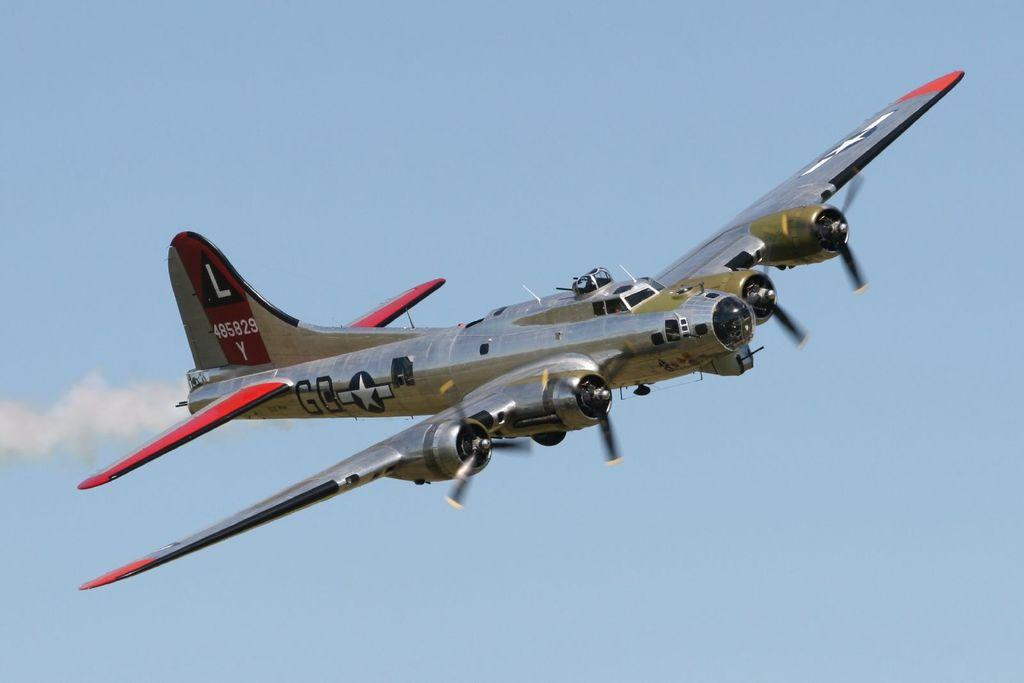<image>
Offer a succinct explanation of the picture presented. An old fashioned plane is flying through the sky with the sign "485829 Y" on the horizontal stabilizer. 